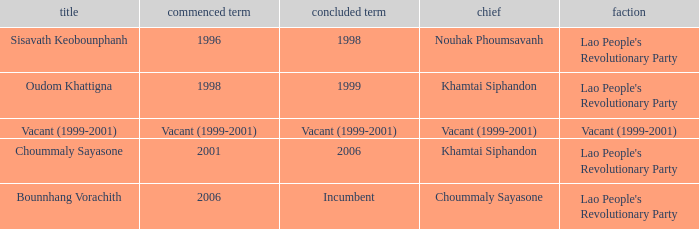Help me parse the entirety of this table. {'header': ['title', 'commenced term', 'concluded term', 'chief', 'faction'], 'rows': [['Sisavath Keobounphanh', '1996', '1998', 'Nouhak Phoumsavanh', "Lao People's Revolutionary Party"], ['Oudom Khattigna', '1998', '1999', 'Khamtai Siphandon', "Lao People's Revolutionary Party"], ['Vacant (1999-2001)', 'Vacant (1999-2001)', 'Vacant (1999-2001)', 'Vacant (1999-2001)', 'Vacant (1999-2001)'], ['Choummaly Sayasone', '2001', '2006', 'Khamtai Siphandon', "Lao People's Revolutionary Party"], ['Bounnhang Vorachith', '2006', 'Incumbent', 'Choummaly Sayasone', "Lao People's Revolutionary Party"]]} What is Name, when President is Khamtai Siphandon, and when Left Office is 1999? Oudom Khattigna. 